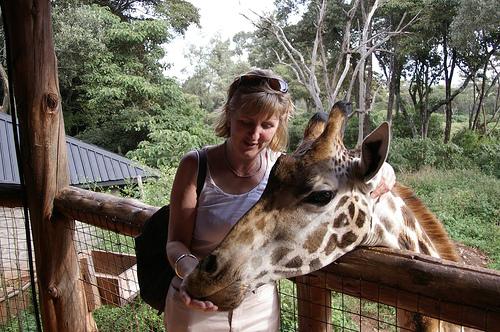Does this take place within an urban area?
Keep it brief. No. What is the woman doing with the giraffe?
Concise answer only. Feeding. What is the woman staring at?
Quick response, please. Giraffe. 